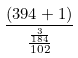<formula> <loc_0><loc_0><loc_500><loc_500>\frac { ( 3 9 4 + 1 ) } { \frac { \frac { 3 } { 1 8 4 } } { 1 0 2 } }</formula> 